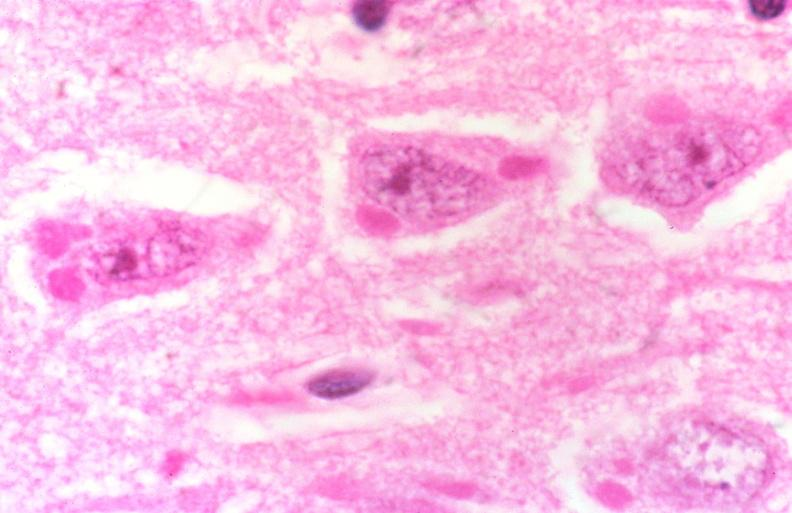what does this image show?
Answer the question using a single word or phrase. Rabies 